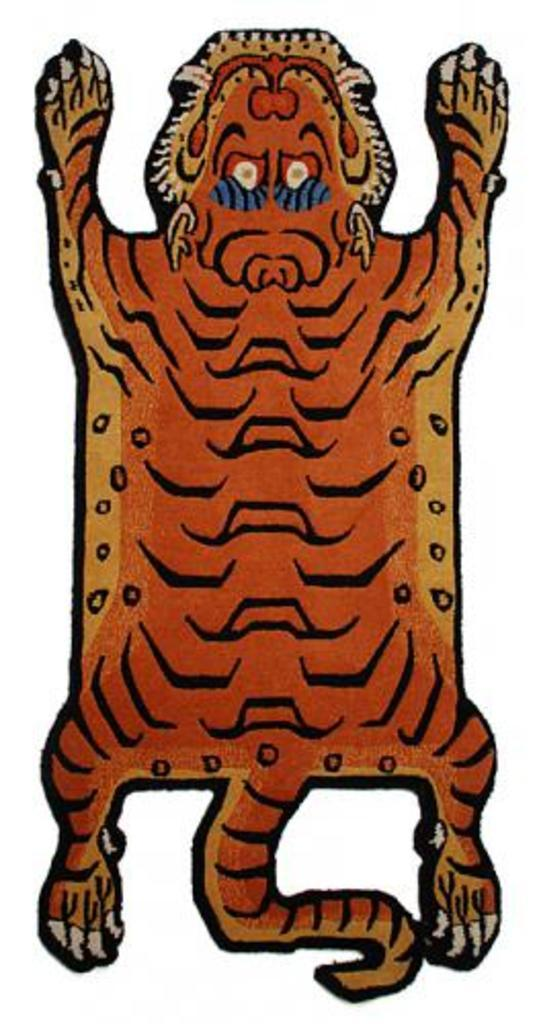What is the main subject of the painting in the image? There is a painting of an animal in the image. What color is the background of the painting? The background of the image is white in color. What song is the animal singing in the image? There is no indication that the animal is singing a song in the image. 